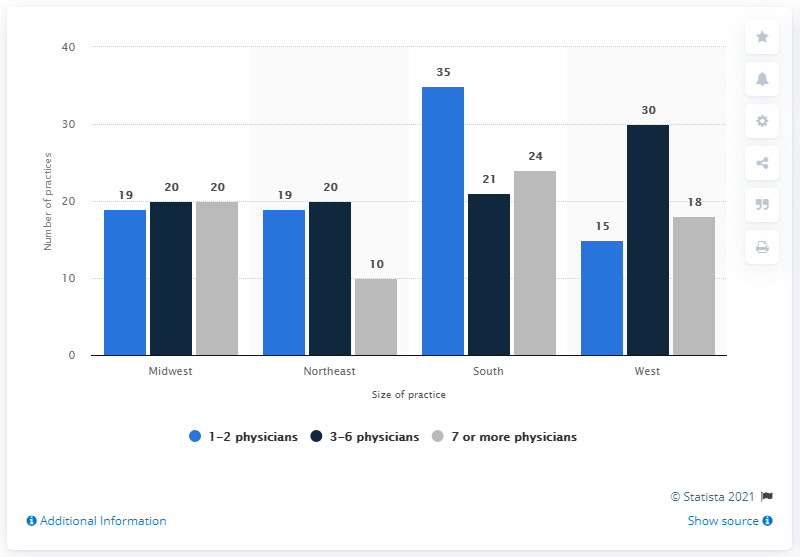Point out several critical features in this image. In 2013, there were 15 private community oncology practices in the western region of the United States. 